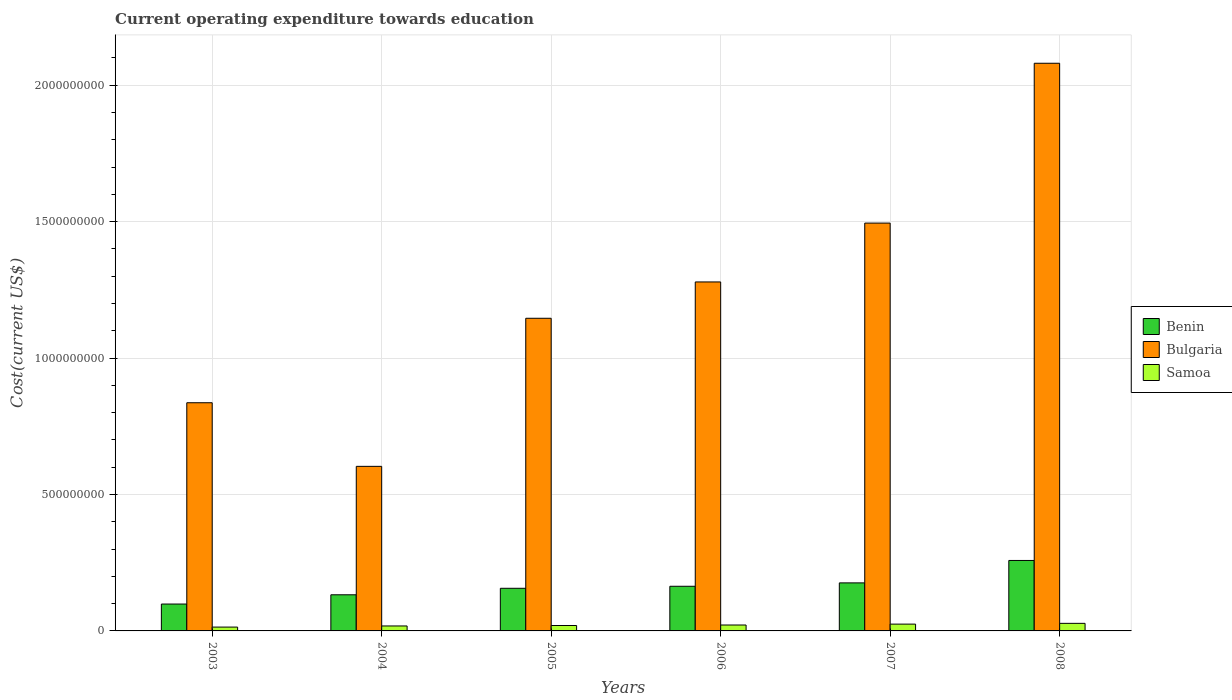Are the number of bars per tick equal to the number of legend labels?
Offer a terse response. Yes. Are the number of bars on each tick of the X-axis equal?
Your answer should be very brief. Yes. How many bars are there on the 4th tick from the left?
Offer a terse response. 3. In how many cases, is the number of bars for a given year not equal to the number of legend labels?
Your response must be concise. 0. What is the expenditure towards education in Bulgaria in 2003?
Keep it short and to the point. 8.36e+08. Across all years, what is the maximum expenditure towards education in Benin?
Offer a terse response. 2.58e+08. Across all years, what is the minimum expenditure towards education in Samoa?
Make the answer very short. 1.41e+07. In which year was the expenditure towards education in Benin maximum?
Give a very brief answer. 2008. In which year was the expenditure towards education in Benin minimum?
Your answer should be compact. 2003. What is the total expenditure towards education in Bulgaria in the graph?
Keep it short and to the point. 7.44e+09. What is the difference between the expenditure towards education in Bulgaria in 2005 and that in 2007?
Keep it short and to the point. -3.49e+08. What is the difference between the expenditure towards education in Benin in 2007 and the expenditure towards education in Bulgaria in 2005?
Your answer should be very brief. -9.70e+08. What is the average expenditure towards education in Benin per year?
Your response must be concise. 1.64e+08. In the year 2004, what is the difference between the expenditure towards education in Samoa and expenditure towards education in Bulgaria?
Your answer should be compact. -5.85e+08. What is the ratio of the expenditure towards education in Benin in 2003 to that in 2007?
Keep it short and to the point. 0.56. Is the expenditure towards education in Bulgaria in 2005 less than that in 2006?
Your answer should be very brief. Yes. Is the difference between the expenditure towards education in Samoa in 2006 and 2007 greater than the difference between the expenditure towards education in Bulgaria in 2006 and 2007?
Provide a short and direct response. Yes. What is the difference between the highest and the second highest expenditure towards education in Bulgaria?
Keep it short and to the point. 5.86e+08. What is the difference between the highest and the lowest expenditure towards education in Bulgaria?
Keep it short and to the point. 1.48e+09. What does the 3rd bar from the left in 2007 represents?
Ensure brevity in your answer.  Samoa. What does the 2nd bar from the right in 2006 represents?
Provide a short and direct response. Bulgaria. Is it the case that in every year, the sum of the expenditure towards education in Bulgaria and expenditure towards education in Benin is greater than the expenditure towards education in Samoa?
Offer a terse response. Yes. How many bars are there?
Give a very brief answer. 18. Are all the bars in the graph horizontal?
Give a very brief answer. No. How many years are there in the graph?
Ensure brevity in your answer.  6. Are the values on the major ticks of Y-axis written in scientific E-notation?
Make the answer very short. No. Does the graph contain any zero values?
Provide a short and direct response. No. Does the graph contain grids?
Ensure brevity in your answer.  Yes. Where does the legend appear in the graph?
Give a very brief answer. Center right. How are the legend labels stacked?
Offer a very short reply. Vertical. What is the title of the graph?
Make the answer very short. Current operating expenditure towards education. What is the label or title of the Y-axis?
Ensure brevity in your answer.  Cost(current US$). What is the Cost(current US$) of Benin in 2003?
Offer a terse response. 9.85e+07. What is the Cost(current US$) in Bulgaria in 2003?
Provide a succinct answer. 8.36e+08. What is the Cost(current US$) of Samoa in 2003?
Ensure brevity in your answer.  1.41e+07. What is the Cost(current US$) of Benin in 2004?
Offer a terse response. 1.32e+08. What is the Cost(current US$) of Bulgaria in 2004?
Offer a terse response. 6.03e+08. What is the Cost(current US$) in Samoa in 2004?
Your answer should be compact. 1.82e+07. What is the Cost(current US$) of Benin in 2005?
Offer a very short reply. 1.56e+08. What is the Cost(current US$) in Bulgaria in 2005?
Give a very brief answer. 1.15e+09. What is the Cost(current US$) in Samoa in 2005?
Offer a very short reply. 1.99e+07. What is the Cost(current US$) of Benin in 2006?
Offer a very short reply. 1.64e+08. What is the Cost(current US$) in Bulgaria in 2006?
Ensure brevity in your answer.  1.28e+09. What is the Cost(current US$) of Samoa in 2006?
Offer a very short reply. 2.17e+07. What is the Cost(current US$) of Benin in 2007?
Your response must be concise. 1.76e+08. What is the Cost(current US$) of Bulgaria in 2007?
Keep it short and to the point. 1.49e+09. What is the Cost(current US$) in Samoa in 2007?
Your answer should be very brief. 2.50e+07. What is the Cost(current US$) in Benin in 2008?
Your response must be concise. 2.58e+08. What is the Cost(current US$) of Bulgaria in 2008?
Ensure brevity in your answer.  2.08e+09. What is the Cost(current US$) of Samoa in 2008?
Give a very brief answer. 2.78e+07. Across all years, what is the maximum Cost(current US$) in Benin?
Offer a very short reply. 2.58e+08. Across all years, what is the maximum Cost(current US$) in Bulgaria?
Provide a short and direct response. 2.08e+09. Across all years, what is the maximum Cost(current US$) in Samoa?
Ensure brevity in your answer.  2.78e+07. Across all years, what is the minimum Cost(current US$) in Benin?
Offer a terse response. 9.85e+07. Across all years, what is the minimum Cost(current US$) of Bulgaria?
Offer a very short reply. 6.03e+08. Across all years, what is the minimum Cost(current US$) of Samoa?
Your response must be concise. 1.41e+07. What is the total Cost(current US$) of Benin in the graph?
Keep it short and to the point. 9.85e+08. What is the total Cost(current US$) in Bulgaria in the graph?
Offer a very short reply. 7.44e+09. What is the total Cost(current US$) of Samoa in the graph?
Your response must be concise. 1.27e+08. What is the difference between the Cost(current US$) in Benin in 2003 and that in 2004?
Make the answer very short. -3.39e+07. What is the difference between the Cost(current US$) of Bulgaria in 2003 and that in 2004?
Keep it short and to the point. 2.33e+08. What is the difference between the Cost(current US$) of Samoa in 2003 and that in 2004?
Your answer should be very brief. -4.14e+06. What is the difference between the Cost(current US$) of Benin in 2003 and that in 2005?
Offer a very short reply. -5.77e+07. What is the difference between the Cost(current US$) of Bulgaria in 2003 and that in 2005?
Provide a succinct answer. -3.10e+08. What is the difference between the Cost(current US$) in Samoa in 2003 and that in 2005?
Provide a short and direct response. -5.81e+06. What is the difference between the Cost(current US$) of Benin in 2003 and that in 2006?
Offer a terse response. -6.51e+07. What is the difference between the Cost(current US$) in Bulgaria in 2003 and that in 2006?
Ensure brevity in your answer.  -4.43e+08. What is the difference between the Cost(current US$) of Samoa in 2003 and that in 2006?
Make the answer very short. -7.64e+06. What is the difference between the Cost(current US$) of Benin in 2003 and that in 2007?
Keep it short and to the point. -7.76e+07. What is the difference between the Cost(current US$) in Bulgaria in 2003 and that in 2007?
Your response must be concise. -6.59e+08. What is the difference between the Cost(current US$) in Samoa in 2003 and that in 2007?
Provide a short and direct response. -1.09e+07. What is the difference between the Cost(current US$) of Benin in 2003 and that in 2008?
Provide a short and direct response. -1.60e+08. What is the difference between the Cost(current US$) in Bulgaria in 2003 and that in 2008?
Keep it short and to the point. -1.24e+09. What is the difference between the Cost(current US$) of Samoa in 2003 and that in 2008?
Ensure brevity in your answer.  -1.37e+07. What is the difference between the Cost(current US$) in Benin in 2004 and that in 2005?
Give a very brief answer. -2.38e+07. What is the difference between the Cost(current US$) of Bulgaria in 2004 and that in 2005?
Your response must be concise. -5.43e+08. What is the difference between the Cost(current US$) in Samoa in 2004 and that in 2005?
Your response must be concise. -1.66e+06. What is the difference between the Cost(current US$) in Benin in 2004 and that in 2006?
Keep it short and to the point. -3.12e+07. What is the difference between the Cost(current US$) in Bulgaria in 2004 and that in 2006?
Your answer should be very brief. -6.76e+08. What is the difference between the Cost(current US$) in Samoa in 2004 and that in 2006?
Provide a succinct answer. -3.50e+06. What is the difference between the Cost(current US$) of Benin in 2004 and that in 2007?
Make the answer very short. -4.36e+07. What is the difference between the Cost(current US$) of Bulgaria in 2004 and that in 2007?
Your answer should be very brief. -8.92e+08. What is the difference between the Cost(current US$) in Samoa in 2004 and that in 2007?
Provide a short and direct response. -6.76e+06. What is the difference between the Cost(current US$) in Benin in 2004 and that in 2008?
Offer a very short reply. -1.26e+08. What is the difference between the Cost(current US$) in Bulgaria in 2004 and that in 2008?
Provide a succinct answer. -1.48e+09. What is the difference between the Cost(current US$) in Samoa in 2004 and that in 2008?
Make the answer very short. -9.57e+06. What is the difference between the Cost(current US$) in Benin in 2005 and that in 2006?
Offer a very short reply. -7.40e+06. What is the difference between the Cost(current US$) in Bulgaria in 2005 and that in 2006?
Offer a very short reply. -1.33e+08. What is the difference between the Cost(current US$) in Samoa in 2005 and that in 2006?
Your answer should be very brief. -1.83e+06. What is the difference between the Cost(current US$) in Benin in 2005 and that in 2007?
Your answer should be compact. -1.98e+07. What is the difference between the Cost(current US$) of Bulgaria in 2005 and that in 2007?
Offer a very short reply. -3.49e+08. What is the difference between the Cost(current US$) in Samoa in 2005 and that in 2007?
Your answer should be compact. -5.10e+06. What is the difference between the Cost(current US$) in Benin in 2005 and that in 2008?
Give a very brief answer. -1.02e+08. What is the difference between the Cost(current US$) in Bulgaria in 2005 and that in 2008?
Your answer should be compact. -9.35e+08. What is the difference between the Cost(current US$) of Samoa in 2005 and that in 2008?
Your answer should be compact. -7.91e+06. What is the difference between the Cost(current US$) in Benin in 2006 and that in 2007?
Your answer should be very brief. -1.24e+07. What is the difference between the Cost(current US$) in Bulgaria in 2006 and that in 2007?
Give a very brief answer. -2.16e+08. What is the difference between the Cost(current US$) in Samoa in 2006 and that in 2007?
Your response must be concise. -3.27e+06. What is the difference between the Cost(current US$) in Benin in 2006 and that in 2008?
Offer a very short reply. -9.46e+07. What is the difference between the Cost(current US$) in Bulgaria in 2006 and that in 2008?
Your answer should be very brief. -8.02e+08. What is the difference between the Cost(current US$) of Samoa in 2006 and that in 2008?
Make the answer very short. -6.08e+06. What is the difference between the Cost(current US$) in Benin in 2007 and that in 2008?
Provide a short and direct response. -8.22e+07. What is the difference between the Cost(current US$) of Bulgaria in 2007 and that in 2008?
Keep it short and to the point. -5.86e+08. What is the difference between the Cost(current US$) of Samoa in 2007 and that in 2008?
Offer a terse response. -2.81e+06. What is the difference between the Cost(current US$) in Benin in 2003 and the Cost(current US$) in Bulgaria in 2004?
Your answer should be compact. -5.05e+08. What is the difference between the Cost(current US$) in Benin in 2003 and the Cost(current US$) in Samoa in 2004?
Give a very brief answer. 8.03e+07. What is the difference between the Cost(current US$) in Bulgaria in 2003 and the Cost(current US$) in Samoa in 2004?
Provide a short and direct response. 8.18e+08. What is the difference between the Cost(current US$) of Benin in 2003 and the Cost(current US$) of Bulgaria in 2005?
Provide a succinct answer. -1.05e+09. What is the difference between the Cost(current US$) of Benin in 2003 and the Cost(current US$) of Samoa in 2005?
Give a very brief answer. 7.87e+07. What is the difference between the Cost(current US$) in Bulgaria in 2003 and the Cost(current US$) in Samoa in 2005?
Your response must be concise. 8.16e+08. What is the difference between the Cost(current US$) of Benin in 2003 and the Cost(current US$) of Bulgaria in 2006?
Your response must be concise. -1.18e+09. What is the difference between the Cost(current US$) in Benin in 2003 and the Cost(current US$) in Samoa in 2006?
Provide a succinct answer. 7.68e+07. What is the difference between the Cost(current US$) of Bulgaria in 2003 and the Cost(current US$) of Samoa in 2006?
Your answer should be very brief. 8.15e+08. What is the difference between the Cost(current US$) of Benin in 2003 and the Cost(current US$) of Bulgaria in 2007?
Offer a terse response. -1.40e+09. What is the difference between the Cost(current US$) of Benin in 2003 and the Cost(current US$) of Samoa in 2007?
Your response must be concise. 7.36e+07. What is the difference between the Cost(current US$) of Bulgaria in 2003 and the Cost(current US$) of Samoa in 2007?
Provide a succinct answer. 8.11e+08. What is the difference between the Cost(current US$) of Benin in 2003 and the Cost(current US$) of Bulgaria in 2008?
Your answer should be compact. -1.98e+09. What is the difference between the Cost(current US$) in Benin in 2003 and the Cost(current US$) in Samoa in 2008?
Your answer should be compact. 7.08e+07. What is the difference between the Cost(current US$) of Bulgaria in 2003 and the Cost(current US$) of Samoa in 2008?
Keep it short and to the point. 8.09e+08. What is the difference between the Cost(current US$) of Benin in 2004 and the Cost(current US$) of Bulgaria in 2005?
Your response must be concise. -1.01e+09. What is the difference between the Cost(current US$) in Benin in 2004 and the Cost(current US$) in Samoa in 2005?
Offer a very short reply. 1.13e+08. What is the difference between the Cost(current US$) of Bulgaria in 2004 and the Cost(current US$) of Samoa in 2005?
Offer a very short reply. 5.83e+08. What is the difference between the Cost(current US$) in Benin in 2004 and the Cost(current US$) in Bulgaria in 2006?
Your answer should be compact. -1.15e+09. What is the difference between the Cost(current US$) in Benin in 2004 and the Cost(current US$) in Samoa in 2006?
Keep it short and to the point. 1.11e+08. What is the difference between the Cost(current US$) in Bulgaria in 2004 and the Cost(current US$) in Samoa in 2006?
Keep it short and to the point. 5.81e+08. What is the difference between the Cost(current US$) in Benin in 2004 and the Cost(current US$) in Bulgaria in 2007?
Give a very brief answer. -1.36e+09. What is the difference between the Cost(current US$) in Benin in 2004 and the Cost(current US$) in Samoa in 2007?
Offer a very short reply. 1.08e+08. What is the difference between the Cost(current US$) in Bulgaria in 2004 and the Cost(current US$) in Samoa in 2007?
Provide a succinct answer. 5.78e+08. What is the difference between the Cost(current US$) of Benin in 2004 and the Cost(current US$) of Bulgaria in 2008?
Provide a short and direct response. -1.95e+09. What is the difference between the Cost(current US$) of Benin in 2004 and the Cost(current US$) of Samoa in 2008?
Your answer should be compact. 1.05e+08. What is the difference between the Cost(current US$) of Bulgaria in 2004 and the Cost(current US$) of Samoa in 2008?
Ensure brevity in your answer.  5.75e+08. What is the difference between the Cost(current US$) in Benin in 2005 and the Cost(current US$) in Bulgaria in 2006?
Give a very brief answer. -1.12e+09. What is the difference between the Cost(current US$) of Benin in 2005 and the Cost(current US$) of Samoa in 2006?
Provide a short and direct response. 1.35e+08. What is the difference between the Cost(current US$) in Bulgaria in 2005 and the Cost(current US$) in Samoa in 2006?
Your answer should be compact. 1.12e+09. What is the difference between the Cost(current US$) in Benin in 2005 and the Cost(current US$) in Bulgaria in 2007?
Offer a terse response. -1.34e+09. What is the difference between the Cost(current US$) of Benin in 2005 and the Cost(current US$) of Samoa in 2007?
Your answer should be compact. 1.31e+08. What is the difference between the Cost(current US$) in Bulgaria in 2005 and the Cost(current US$) in Samoa in 2007?
Provide a succinct answer. 1.12e+09. What is the difference between the Cost(current US$) in Benin in 2005 and the Cost(current US$) in Bulgaria in 2008?
Ensure brevity in your answer.  -1.92e+09. What is the difference between the Cost(current US$) of Benin in 2005 and the Cost(current US$) of Samoa in 2008?
Ensure brevity in your answer.  1.28e+08. What is the difference between the Cost(current US$) in Bulgaria in 2005 and the Cost(current US$) in Samoa in 2008?
Offer a very short reply. 1.12e+09. What is the difference between the Cost(current US$) in Benin in 2006 and the Cost(current US$) in Bulgaria in 2007?
Keep it short and to the point. -1.33e+09. What is the difference between the Cost(current US$) of Benin in 2006 and the Cost(current US$) of Samoa in 2007?
Your answer should be compact. 1.39e+08. What is the difference between the Cost(current US$) in Bulgaria in 2006 and the Cost(current US$) in Samoa in 2007?
Your response must be concise. 1.25e+09. What is the difference between the Cost(current US$) in Benin in 2006 and the Cost(current US$) in Bulgaria in 2008?
Your answer should be compact. -1.92e+09. What is the difference between the Cost(current US$) of Benin in 2006 and the Cost(current US$) of Samoa in 2008?
Your response must be concise. 1.36e+08. What is the difference between the Cost(current US$) of Bulgaria in 2006 and the Cost(current US$) of Samoa in 2008?
Your answer should be compact. 1.25e+09. What is the difference between the Cost(current US$) of Benin in 2007 and the Cost(current US$) of Bulgaria in 2008?
Your response must be concise. -1.90e+09. What is the difference between the Cost(current US$) of Benin in 2007 and the Cost(current US$) of Samoa in 2008?
Your answer should be compact. 1.48e+08. What is the difference between the Cost(current US$) of Bulgaria in 2007 and the Cost(current US$) of Samoa in 2008?
Provide a short and direct response. 1.47e+09. What is the average Cost(current US$) in Benin per year?
Offer a terse response. 1.64e+08. What is the average Cost(current US$) in Bulgaria per year?
Your answer should be very brief. 1.24e+09. What is the average Cost(current US$) in Samoa per year?
Your answer should be very brief. 2.11e+07. In the year 2003, what is the difference between the Cost(current US$) of Benin and Cost(current US$) of Bulgaria?
Provide a succinct answer. -7.38e+08. In the year 2003, what is the difference between the Cost(current US$) in Benin and Cost(current US$) in Samoa?
Offer a terse response. 8.45e+07. In the year 2003, what is the difference between the Cost(current US$) of Bulgaria and Cost(current US$) of Samoa?
Make the answer very short. 8.22e+08. In the year 2004, what is the difference between the Cost(current US$) of Benin and Cost(current US$) of Bulgaria?
Provide a short and direct response. -4.71e+08. In the year 2004, what is the difference between the Cost(current US$) of Benin and Cost(current US$) of Samoa?
Your answer should be compact. 1.14e+08. In the year 2004, what is the difference between the Cost(current US$) of Bulgaria and Cost(current US$) of Samoa?
Make the answer very short. 5.85e+08. In the year 2005, what is the difference between the Cost(current US$) in Benin and Cost(current US$) in Bulgaria?
Your response must be concise. -9.90e+08. In the year 2005, what is the difference between the Cost(current US$) in Benin and Cost(current US$) in Samoa?
Keep it short and to the point. 1.36e+08. In the year 2005, what is the difference between the Cost(current US$) of Bulgaria and Cost(current US$) of Samoa?
Give a very brief answer. 1.13e+09. In the year 2006, what is the difference between the Cost(current US$) in Benin and Cost(current US$) in Bulgaria?
Your answer should be very brief. -1.12e+09. In the year 2006, what is the difference between the Cost(current US$) of Benin and Cost(current US$) of Samoa?
Your answer should be compact. 1.42e+08. In the year 2006, what is the difference between the Cost(current US$) of Bulgaria and Cost(current US$) of Samoa?
Ensure brevity in your answer.  1.26e+09. In the year 2007, what is the difference between the Cost(current US$) in Benin and Cost(current US$) in Bulgaria?
Give a very brief answer. -1.32e+09. In the year 2007, what is the difference between the Cost(current US$) of Benin and Cost(current US$) of Samoa?
Make the answer very short. 1.51e+08. In the year 2007, what is the difference between the Cost(current US$) in Bulgaria and Cost(current US$) in Samoa?
Your response must be concise. 1.47e+09. In the year 2008, what is the difference between the Cost(current US$) of Benin and Cost(current US$) of Bulgaria?
Offer a terse response. -1.82e+09. In the year 2008, what is the difference between the Cost(current US$) of Benin and Cost(current US$) of Samoa?
Give a very brief answer. 2.30e+08. In the year 2008, what is the difference between the Cost(current US$) in Bulgaria and Cost(current US$) in Samoa?
Give a very brief answer. 2.05e+09. What is the ratio of the Cost(current US$) in Benin in 2003 to that in 2004?
Give a very brief answer. 0.74. What is the ratio of the Cost(current US$) of Bulgaria in 2003 to that in 2004?
Keep it short and to the point. 1.39. What is the ratio of the Cost(current US$) in Samoa in 2003 to that in 2004?
Offer a terse response. 0.77. What is the ratio of the Cost(current US$) in Benin in 2003 to that in 2005?
Offer a very short reply. 0.63. What is the ratio of the Cost(current US$) in Bulgaria in 2003 to that in 2005?
Your response must be concise. 0.73. What is the ratio of the Cost(current US$) in Samoa in 2003 to that in 2005?
Offer a very short reply. 0.71. What is the ratio of the Cost(current US$) of Benin in 2003 to that in 2006?
Your response must be concise. 0.6. What is the ratio of the Cost(current US$) in Bulgaria in 2003 to that in 2006?
Provide a short and direct response. 0.65. What is the ratio of the Cost(current US$) of Samoa in 2003 to that in 2006?
Offer a terse response. 0.65. What is the ratio of the Cost(current US$) of Benin in 2003 to that in 2007?
Give a very brief answer. 0.56. What is the ratio of the Cost(current US$) of Bulgaria in 2003 to that in 2007?
Offer a terse response. 0.56. What is the ratio of the Cost(current US$) of Samoa in 2003 to that in 2007?
Offer a terse response. 0.56. What is the ratio of the Cost(current US$) in Benin in 2003 to that in 2008?
Offer a terse response. 0.38. What is the ratio of the Cost(current US$) of Bulgaria in 2003 to that in 2008?
Provide a short and direct response. 0.4. What is the ratio of the Cost(current US$) in Samoa in 2003 to that in 2008?
Your response must be concise. 0.51. What is the ratio of the Cost(current US$) in Benin in 2004 to that in 2005?
Provide a succinct answer. 0.85. What is the ratio of the Cost(current US$) of Bulgaria in 2004 to that in 2005?
Give a very brief answer. 0.53. What is the ratio of the Cost(current US$) of Samoa in 2004 to that in 2005?
Keep it short and to the point. 0.92. What is the ratio of the Cost(current US$) of Benin in 2004 to that in 2006?
Provide a succinct answer. 0.81. What is the ratio of the Cost(current US$) in Bulgaria in 2004 to that in 2006?
Provide a short and direct response. 0.47. What is the ratio of the Cost(current US$) of Samoa in 2004 to that in 2006?
Provide a succinct answer. 0.84. What is the ratio of the Cost(current US$) of Benin in 2004 to that in 2007?
Provide a succinct answer. 0.75. What is the ratio of the Cost(current US$) in Bulgaria in 2004 to that in 2007?
Make the answer very short. 0.4. What is the ratio of the Cost(current US$) in Samoa in 2004 to that in 2007?
Offer a very short reply. 0.73. What is the ratio of the Cost(current US$) of Benin in 2004 to that in 2008?
Your answer should be compact. 0.51. What is the ratio of the Cost(current US$) of Bulgaria in 2004 to that in 2008?
Keep it short and to the point. 0.29. What is the ratio of the Cost(current US$) in Samoa in 2004 to that in 2008?
Keep it short and to the point. 0.66. What is the ratio of the Cost(current US$) in Benin in 2005 to that in 2006?
Ensure brevity in your answer.  0.95. What is the ratio of the Cost(current US$) of Bulgaria in 2005 to that in 2006?
Your response must be concise. 0.9. What is the ratio of the Cost(current US$) of Samoa in 2005 to that in 2006?
Your answer should be compact. 0.92. What is the ratio of the Cost(current US$) in Benin in 2005 to that in 2007?
Provide a short and direct response. 0.89. What is the ratio of the Cost(current US$) in Bulgaria in 2005 to that in 2007?
Your answer should be very brief. 0.77. What is the ratio of the Cost(current US$) in Samoa in 2005 to that in 2007?
Your response must be concise. 0.8. What is the ratio of the Cost(current US$) in Benin in 2005 to that in 2008?
Offer a terse response. 0.6. What is the ratio of the Cost(current US$) in Bulgaria in 2005 to that in 2008?
Your answer should be compact. 0.55. What is the ratio of the Cost(current US$) in Samoa in 2005 to that in 2008?
Offer a very short reply. 0.72. What is the ratio of the Cost(current US$) in Benin in 2006 to that in 2007?
Your response must be concise. 0.93. What is the ratio of the Cost(current US$) in Bulgaria in 2006 to that in 2007?
Your answer should be very brief. 0.86. What is the ratio of the Cost(current US$) of Samoa in 2006 to that in 2007?
Give a very brief answer. 0.87. What is the ratio of the Cost(current US$) in Benin in 2006 to that in 2008?
Offer a terse response. 0.63. What is the ratio of the Cost(current US$) of Bulgaria in 2006 to that in 2008?
Your answer should be very brief. 0.61. What is the ratio of the Cost(current US$) of Samoa in 2006 to that in 2008?
Make the answer very short. 0.78. What is the ratio of the Cost(current US$) in Benin in 2007 to that in 2008?
Provide a succinct answer. 0.68. What is the ratio of the Cost(current US$) in Bulgaria in 2007 to that in 2008?
Keep it short and to the point. 0.72. What is the ratio of the Cost(current US$) of Samoa in 2007 to that in 2008?
Provide a short and direct response. 0.9. What is the difference between the highest and the second highest Cost(current US$) of Benin?
Keep it short and to the point. 8.22e+07. What is the difference between the highest and the second highest Cost(current US$) in Bulgaria?
Your answer should be very brief. 5.86e+08. What is the difference between the highest and the second highest Cost(current US$) of Samoa?
Offer a terse response. 2.81e+06. What is the difference between the highest and the lowest Cost(current US$) in Benin?
Offer a very short reply. 1.60e+08. What is the difference between the highest and the lowest Cost(current US$) in Bulgaria?
Give a very brief answer. 1.48e+09. What is the difference between the highest and the lowest Cost(current US$) in Samoa?
Keep it short and to the point. 1.37e+07. 